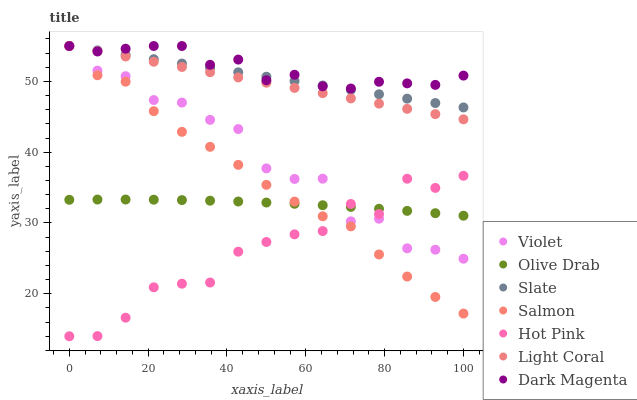Does Hot Pink have the minimum area under the curve?
Answer yes or no. Yes. Does Dark Magenta have the maximum area under the curve?
Answer yes or no. Yes. Does Slate have the minimum area under the curve?
Answer yes or no. No. Does Slate have the maximum area under the curve?
Answer yes or no. No. Is Slate the smoothest?
Answer yes or no. Yes. Is Violet the roughest?
Answer yes or no. Yes. Is Hot Pink the smoothest?
Answer yes or no. No. Is Hot Pink the roughest?
Answer yes or no. No. Does Hot Pink have the lowest value?
Answer yes or no. Yes. Does Slate have the lowest value?
Answer yes or no. No. Does Violet have the highest value?
Answer yes or no. Yes. Does Hot Pink have the highest value?
Answer yes or no. No. Is Olive Drab less than Light Coral?
Answer yes or no. Yes. Is Slate greater than Hot Pink?
Answer yes or no. Yes. Does Dark Magenta intersect Salmon?
Answer yes or no. Yes. Is Dark Magenta less than Salmon?
Answer yes or no. No. Is Dark Magenta greater than Salmon?
Answer yes or no. No. Does Olive Drab intersect Light Coral?
Answer yes or no. No. 